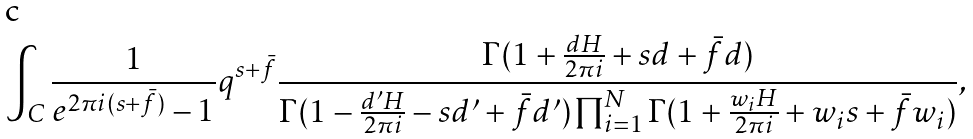<formula> <loc_0><loc_0><loc_500><loc_500>\int _ { C } \frac { 1 } { e ^ { 2 \pi i ( s + \bar { f } ) } - 1 } q ^ { s + \bar { f } } \frac { \Gamma ( 1 + \frac { d H } { 2 \pi i } + s d + \bar { f } d ) } { \Gamma ( 1 - \frac { d ^ { \prime } H } { 2 \pi i } - s d ^ { \prime } + \bar { f } d ^ { \prime } ) \prod _ { i = 1 } ^ { N } \Gamma ( 1 + \frac { w _ { i } H } { 2 \pi i } + w _ { i } s + \bar { f } w _ { i } ) } ,</formula> 